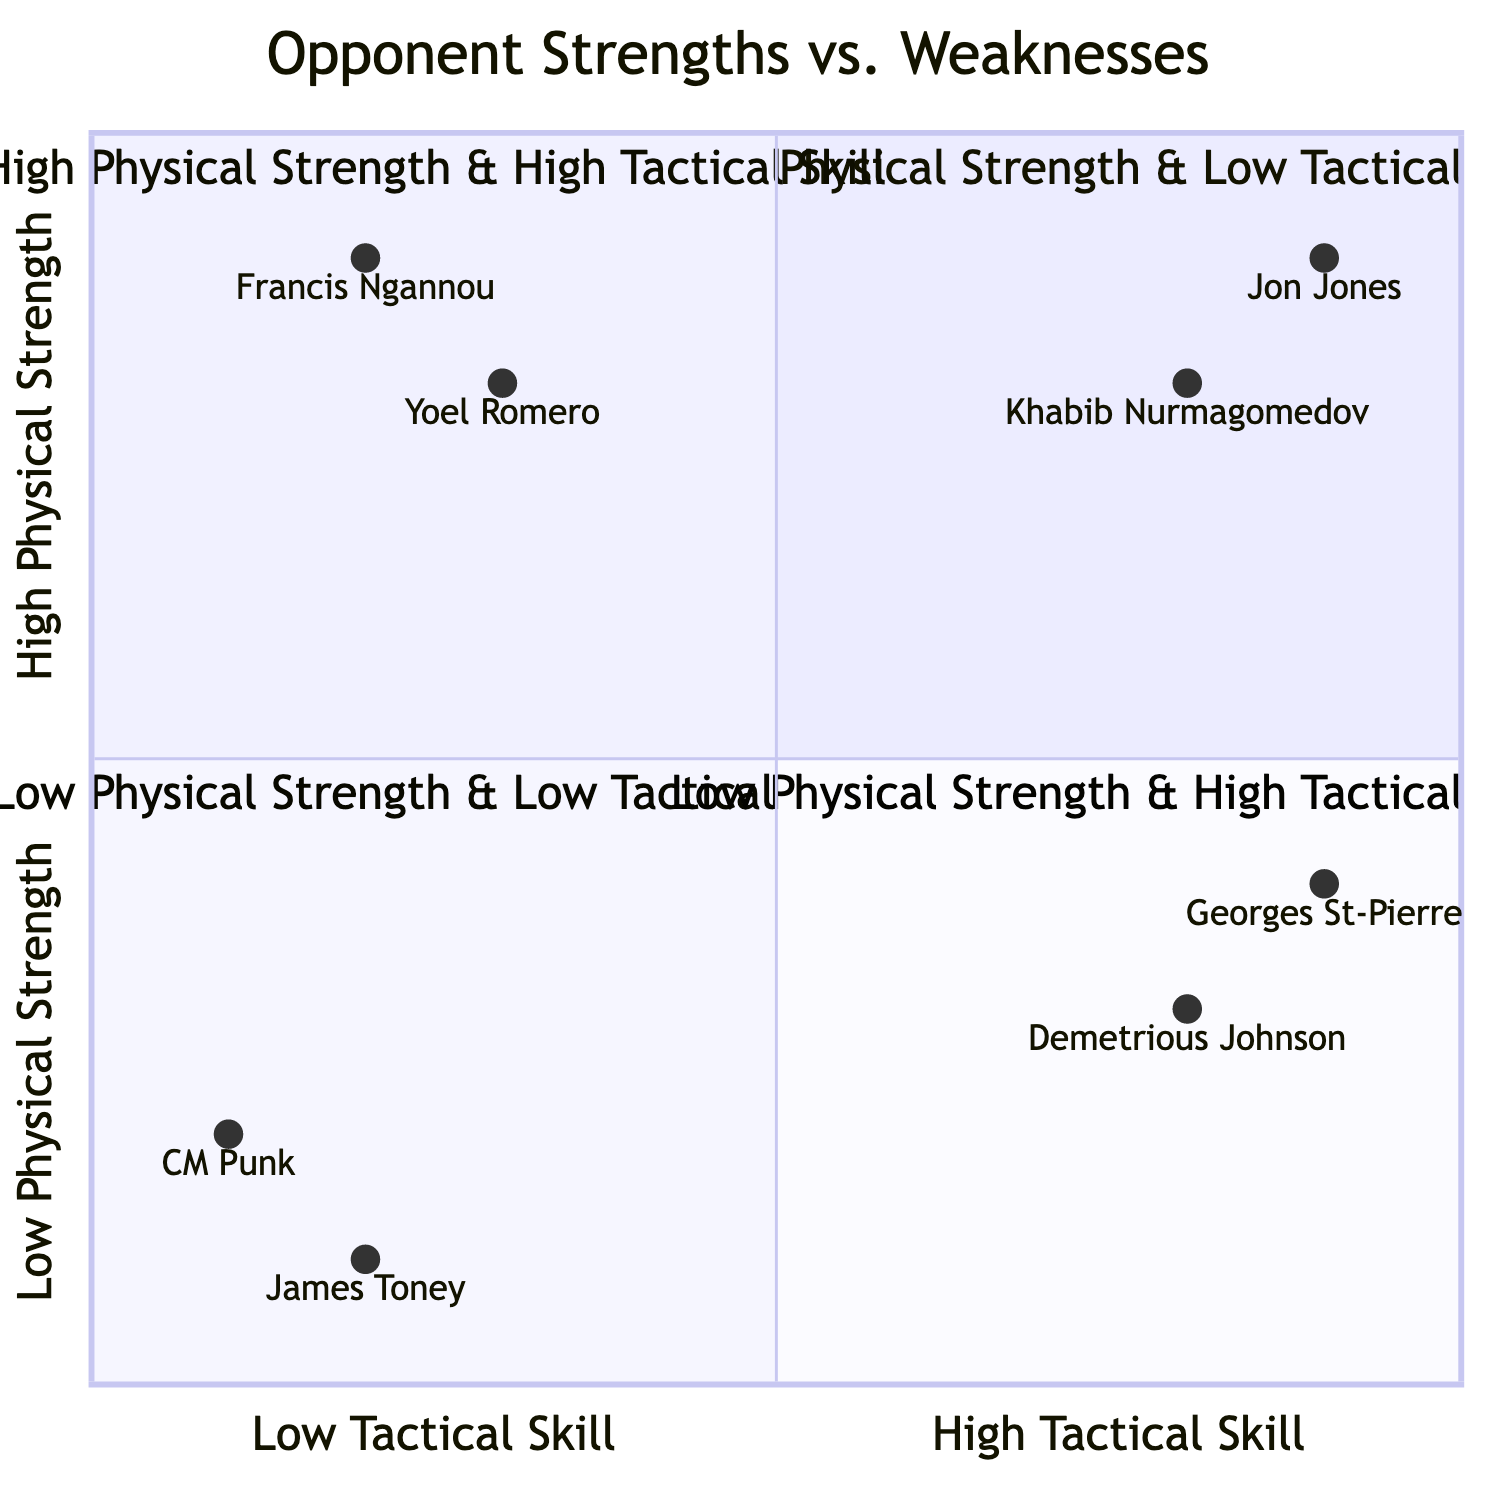What opponents are in the Top-Right quadrant? The Top-Right quadrant represents fighters with high physical strength and high tactical skill. According to the data, the opponents in this quadrant are Jon Jones and Khabib Nurmagomedov.
Answer: Jon Jones, Khabib Nurmagomedov Which fighter has the highest tactical skill in the Bottom-Right quadrant? In the Bottom-Right quadrant, which features fighters with low physical strength but high tactical skill, the fighters listed are Georges St-Pierre and Demetrious Johnson. Among them, Georges St-Pierre is noted for his technical precision and adaptability, while Demetrious Johnson is known for situational awareness and counter-strategy. However, the question specifically asks for the fighter with the highest tactical skill. Both are skilled, but Georges St-Pierre is often regarded as one of the best in terms of tactical approach.
Answer: Georges St-Pierre How many fighters are in the Bottom-Left quadrant? The Bottom-Left quadrant depicts fighters with low physical strength and low tactical skill. The fighters listed in this quadrant are CM Punk and James Toney. Counting these fighters gives a total of two.
Answer: 2 Is Yoel Romero in the Top-Left or Bottom-Right quadrant? Yoel Romero is placed in the Top-Left quadrant, which depicts fighters with high physical strength and low tactical skill. His attributes include raw power and agility, but he also has predictability in his tactics. This distinguishes him from the Bottom-Right quadrant, where the fighters have low physical strength yet high tactical skill.
Answer: Top-Left What is the primary tactical skill of Khabib Nurmagomedov? Khabib Nurmagomedov, who is located in the Top-Right quadrant, is recognized for his pressure strategy and control. This is highlighted in the data under his tactical skill attributes, which show how he effectively implements these strategies during fights.
Answer: Pressure strategy, control Who has more physical strength, Jon Jones or Georges St-Pierre? Comparing the physical strengths noted for Jon Jones and Georges St-Pierre reveals that Jon Jones is characterized by explosive power and a reach advantage, while Georges St-Pierre has endurance and coordination. Judging by this data, Jon Jones has more physical strength than Georges St-Pierre.
Answer: Jon Jones Which quadrant contains Francis Ngannou? Francis Ngannou is situated in the Top-Left quadrant, which categorizes fighters with high physical strength and low tactical skill. His physical attributes include knockout power and athleticism, while his tactical skill is noted to have limitations in ground game and energy management.
Answer: Top-Left What is the tactical skill level of Demetrious Johnson? Demetrious Johnson, located in the Bottom-Right quadrant, is described with high tactical skill attributes, specifically emphasizing situational awareness and counter-strategy. This assessment denotes him as highly tactful within his fighting style, contrasting with the physical strength aspect where he is noted for speed and flexibility.
Answer: High tactical skill Which of the following fighters has the lowest physical strength: CM Punk or James Toney? In the Bottom-Left quadrant, CM Punk has average fitness with limited striking power, while James Toney is described as having an aging physique and slower reflexes. Since both are characterized by low physical strength, James Toney, with the aging physique, is often perceived as weaker in this comparison. However, the question asks for a direct comparison; CM Punk is listed first here with average fitness.
Answer: CM Punk 